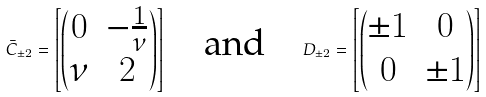Convert formula to latex. <formula><loc_0><loc_0><loc_500><loc_500>\bar { C } _ { \pm 2 } = \left [ \begin{pmatrix} 0 & - \frac { 1 } { \nu } \\ \nu & 2 \end{pmatrix} \right ] \quad \text {and} \quad D _ { \pm 2 } = \left [ \begin{pmatrix} \pm 1 & 0 \\ 0 & \pm 1 \end{pmatrix} \right ]</formula> 